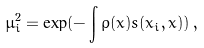<formula> <loc_0><loc_0><loc_500><loc_500>\mu ^ { 2 } _ { i } = \exp ( - \int \rho ( x ) s ( x _ { i } , x ) ) \, ,</formula> 